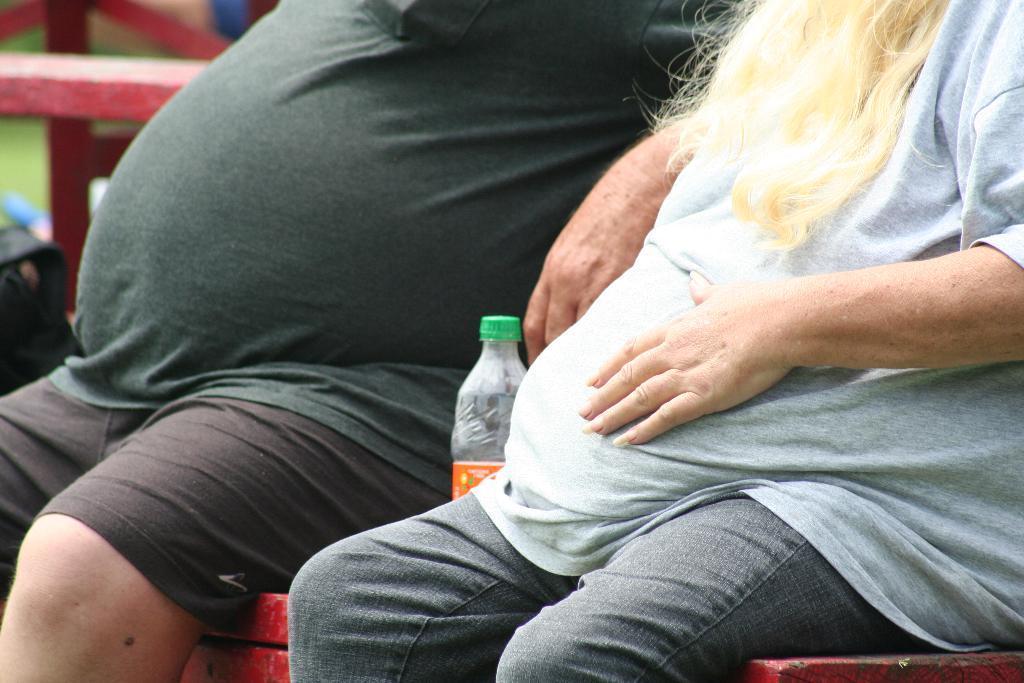Describe this image in one or two sentences. In this image I see 2 persons who are sitting on the red surface and I see a bottle over here. 